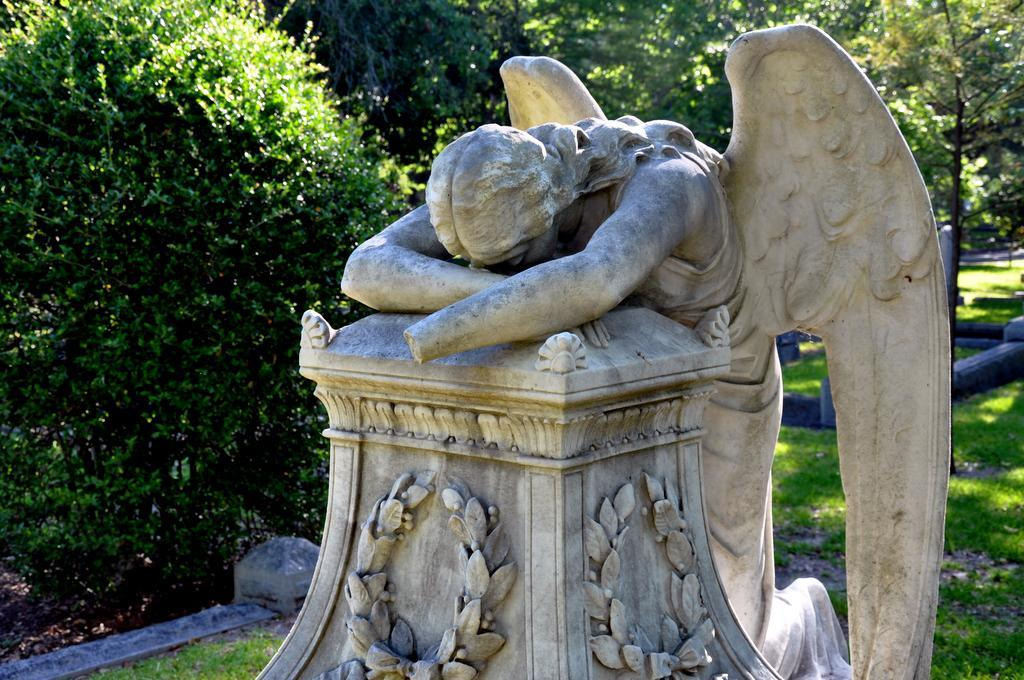What is located on the right side of the image? There is a statue on a platform on the right side of the image. What can be seen on the left side of the image? There are plants and grass on the left side of the image. What is visible in the background of the image? There are trees, poles, and grass in the background of the image. Can you see the force exerted by the statue on the platform in the image? There is no indication of force in the image; it is a static representation of a statue on a platform. Are there any roses visible in the image? There is no mention of roses in the provided facts, and none are visible in the image. 